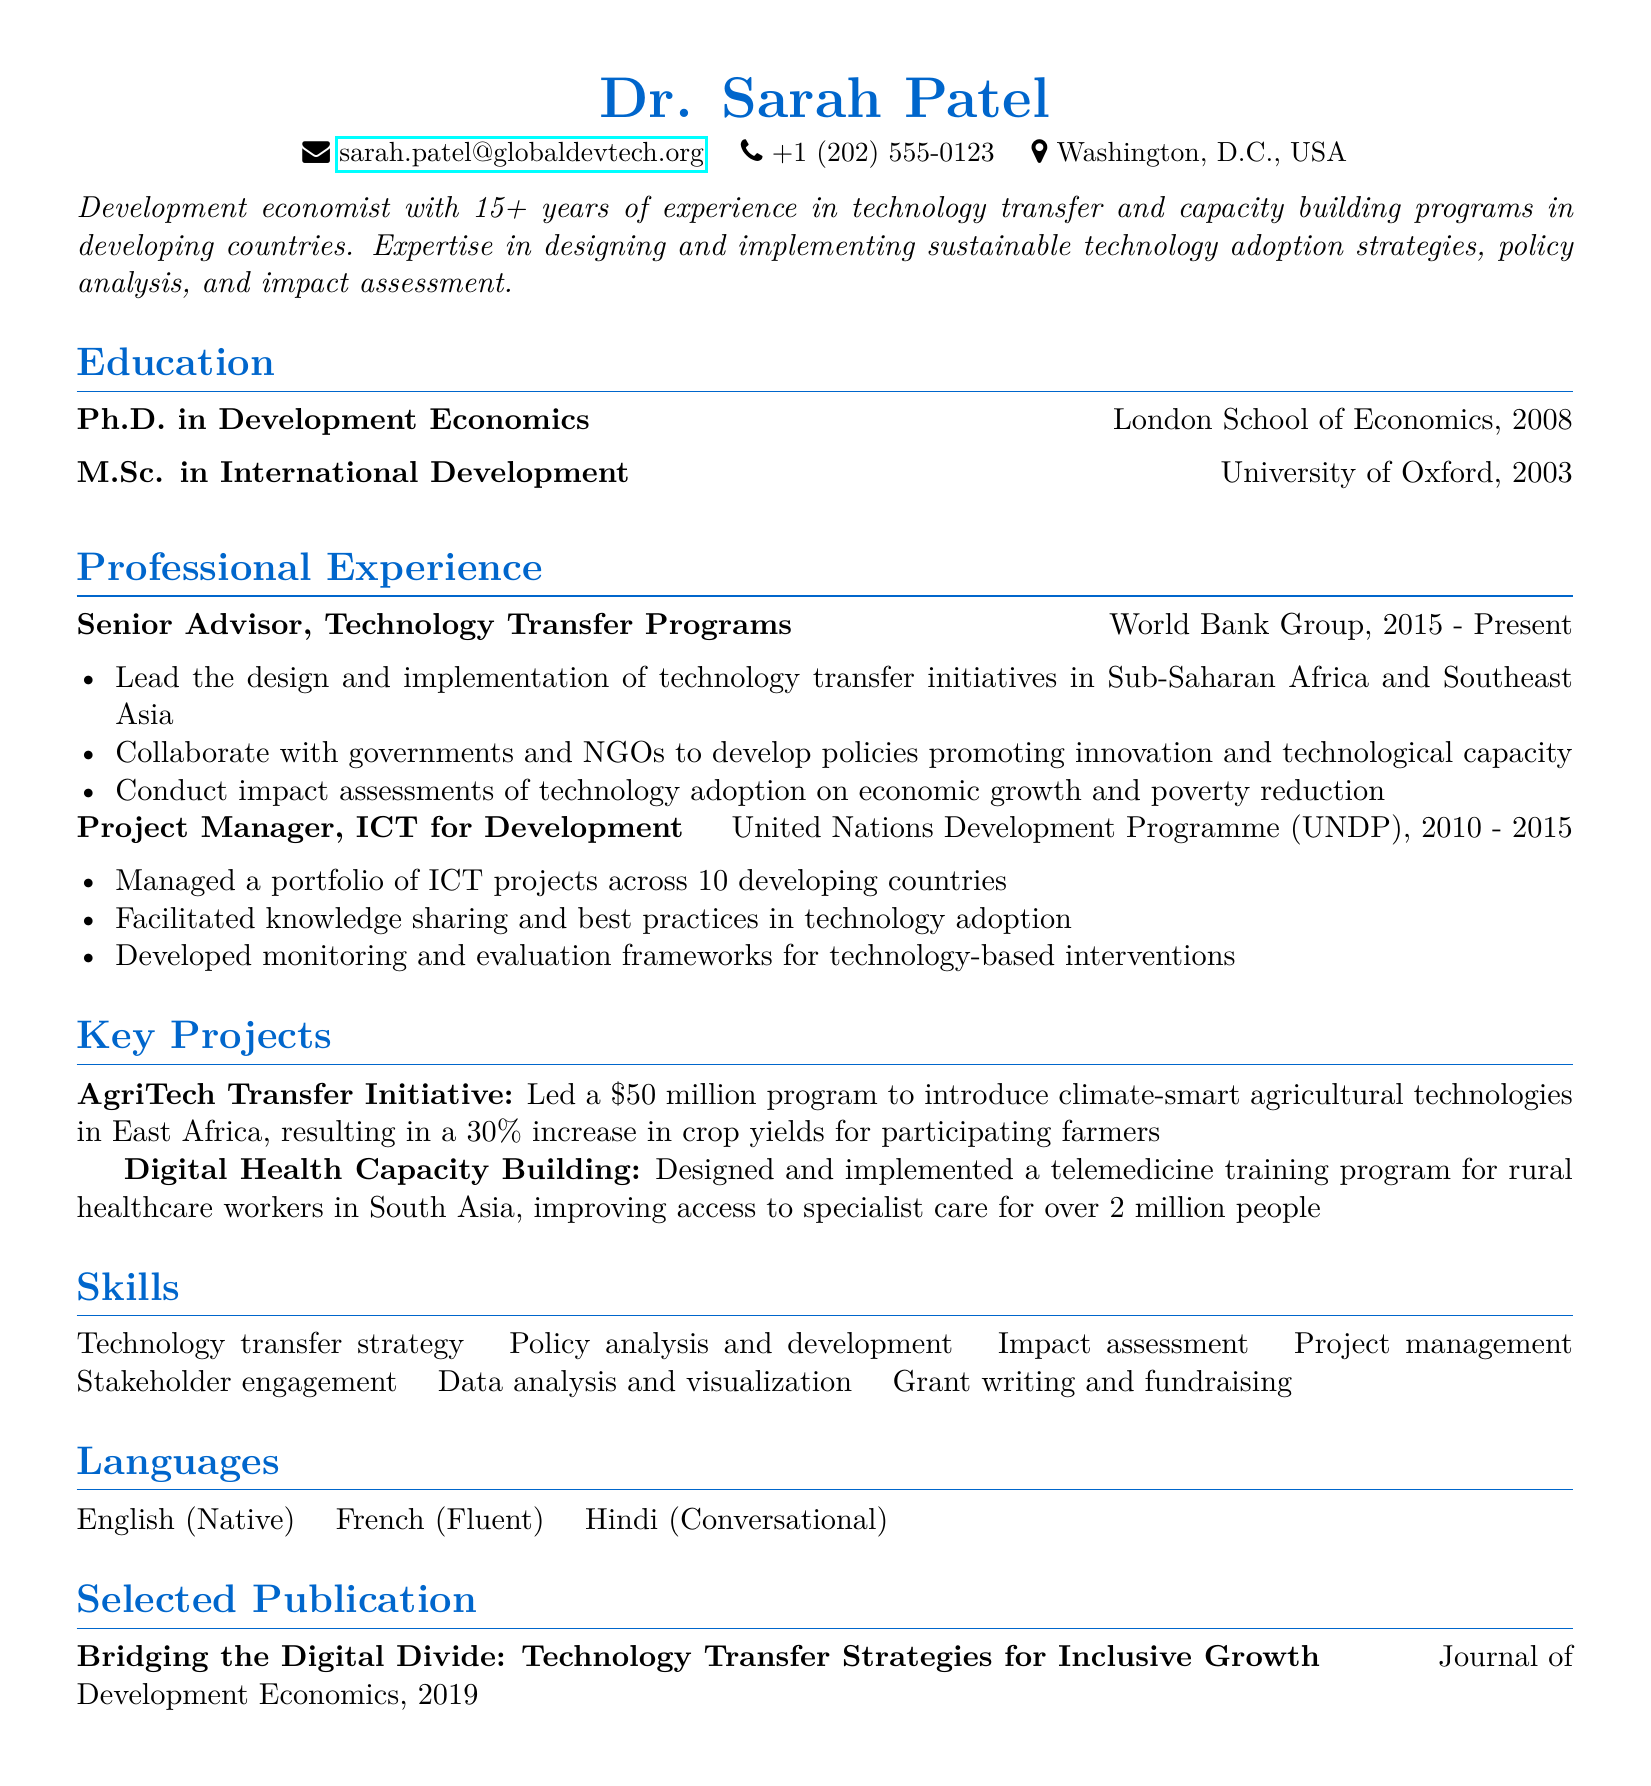what is Dr. Sarah Patel's email address? The email address listed in the document is provided for contact purposes.
Answer: sarah.patel@globaldevtech.org what is Dr. Sarah Patel's highest academic degree? The resume highlights the highest academic degree achieved by Dr. Patel.
Answer: Ph.D. in Development Economics which organization does Dr. Sarah Patel currently work for? The resume states the current employment details of Dr. Patel.
Answer: World Bank Group what was the budget for the AgriTech Transfer Initiative? The document specifies the budget allocated for a specific project Dr. Patel led.
Answer: $50 million how many years of experience does Dr. Sarah Patel have? The summary section provides a total of years working in the field related to technology transfer.
Answer: 15+ years what role did Dr. Sarah Patel have at the UNDP? The resume indicates Dr. Patel's position within the United Nations Development Programme.
Answer: Project Manager what is one language that Dr. Sarah Patel is fluent in? The languages section lists the languages Dr. Patel can communicate in, indicating fluency.
Answer: French which journal published Dr. Patel's selected publication? The publication section mentions where Dr. Patel's research was published.
Answer: Journal of Development Economics what is the primary focus of Dr. Patel's professional expertise? The summary details the main area of specialization for Dr. Patel as mentioned in the document.
Answer: technology transfer and capacity building 